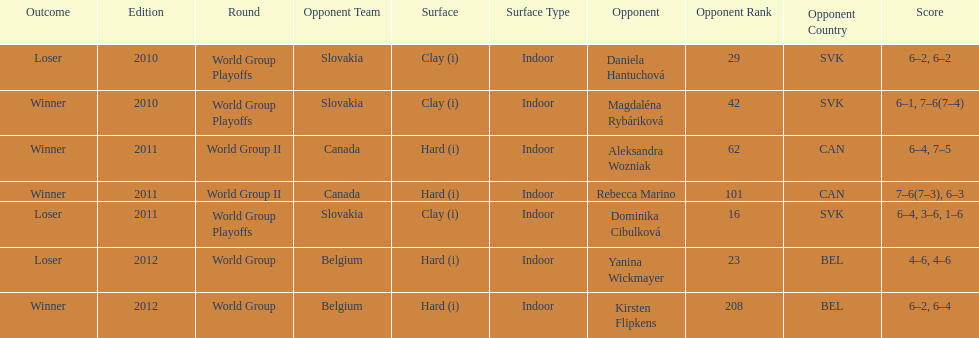What is the other year slovakia played besides 2010? 2011. 